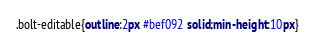Convert code to text. <code><loc_0><loc_0><loc_500><loc_500><_CSS_>.bolt-editable{outline:2px #bef092 solid;min-height:10px}</code> 